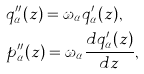Convert formula to latex. <formula><loc_0><loc_0><loc_500><loc_500>& q _ { \alpha } ^ { \prime \prime } ( z ) = \omega _ { \alpha } q _ { \alpha } ^ { \prime } ( z ) , \\ & p _ { \alpha } ^ { \prime \prime } ( z ) = \omega _ { \alpha } \frac { d q _ { \alpha } ^ { \prime } ( z ) } { d z } ,</formula> 